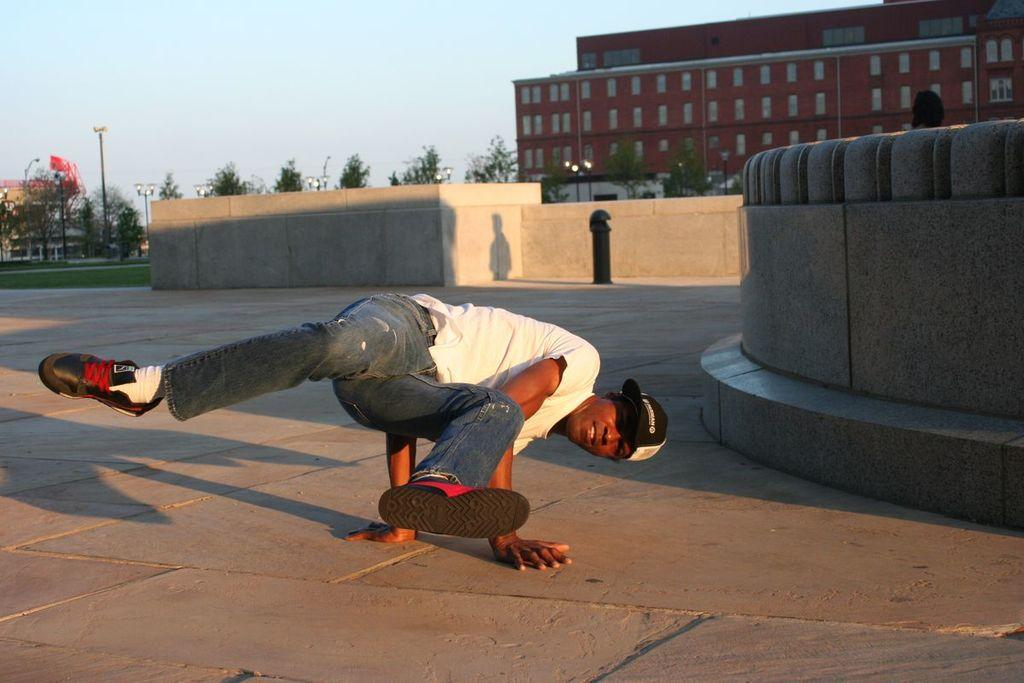What is present in the image? There is a person in the image. What can be seen in the image besides the person? There are trees and a building in the background of the image. What part of the natural environment is visible in the image? The sky is visible in the image. Can you see any wounds on the person in the image? There is no indication of any wounds on the person in the image. What type of pipe is being used by the person in the image? There is no pipe present in the image. 